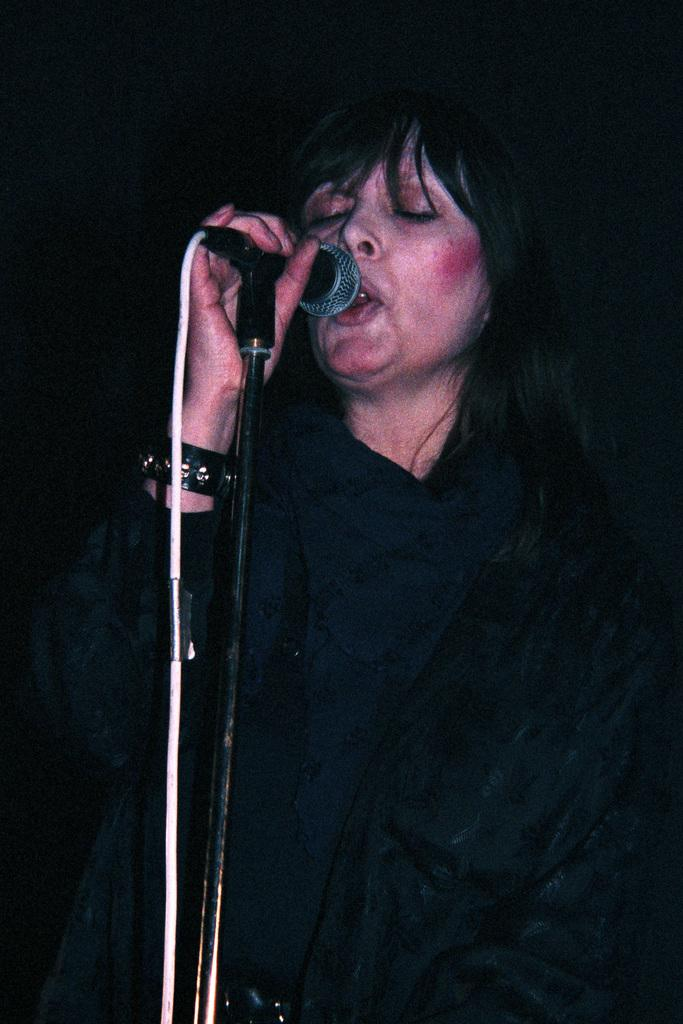What is the main subject of the image? There is a person in the image. What is the person doing in the image? The person is standing. What is the person wearing in the image? The person is wearing a black dress. What object is the person holding in the image? The person is holding a mic. How is the mic positioned in the image? The mic is on a stand. What type of kettle can be seen in the background of the image? There is no kettle present in the image. How does the person's digestion appear to be affected by holding the mic in the image? The image does not provide any information about the person's digestion, and holding a mic would not have a direct impact on digestion. 